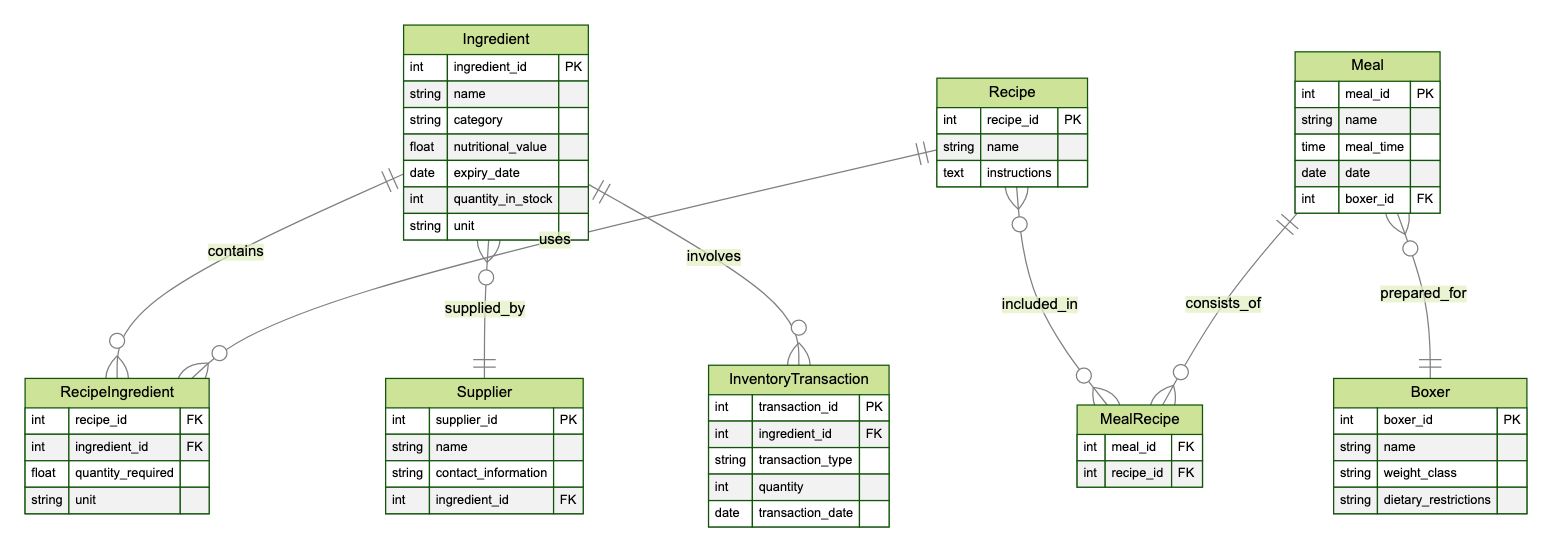What is the primary key of the Ingredient entity? The primary key attribute for the Ingredient entity is ingredient_id, which uniquely identifies each ingredient in the inventory.
Answer: ingredient_id How many entities are present in the diagram? The diagram contains six entities: Ingredient, Supplier, Recipe, Meal, Boxer, and InventoryTransaction.
Answer: 6 Which entity has a one-to-many relationship with the Ingredient entity? The Supplier entity has a one-to-many relationship with the Ingredient entity, indicated by the 'supplies' relationship. Each supplier can supply multiple ingredients.
Answer: Supplier What is the name of the relationship that connects Recipe and Ingredient? The relationship connecting Recipe and Ingredient is called RecipeIngredient, which facilitates the association of specific quantities of ingredients needed for each recipe.
Answer: RecipeIngredient How many relationships are shown between Meal and Recipe? There is one relationship shown between Meal and Recipe, labeled MealRecipe, which shows that meals can consist of multiple recipes and vice versa.
Answer: 1 How many attributes does the Meal entity have? The Meal entity has five attributes: meal_id, name, meal_time, date, and boxer_id, defining various characteristics of a meal.
Answer: 5 What type of relationship exists between the Recipe and Ingredient entities? The relationship between Recipe and Ingredient entities is a many-to-many relationship, indicating that multiple ingredients can be used in multiple recipes.
Answer: many-to-many Which entity can be associated with an InventoryTransaction? The Ingredient entity can be associated with an InventoryTransaction as indicated by the relationship that involves ingredients in inventory transactions.
Answer: Ingredient Which entity is prepared for the Meal entity? The Meal entity is prepared for the Boxer entity, as shown by the relationship indicating that each meal is tailored for a specific boxer.
Answer: Boxer 